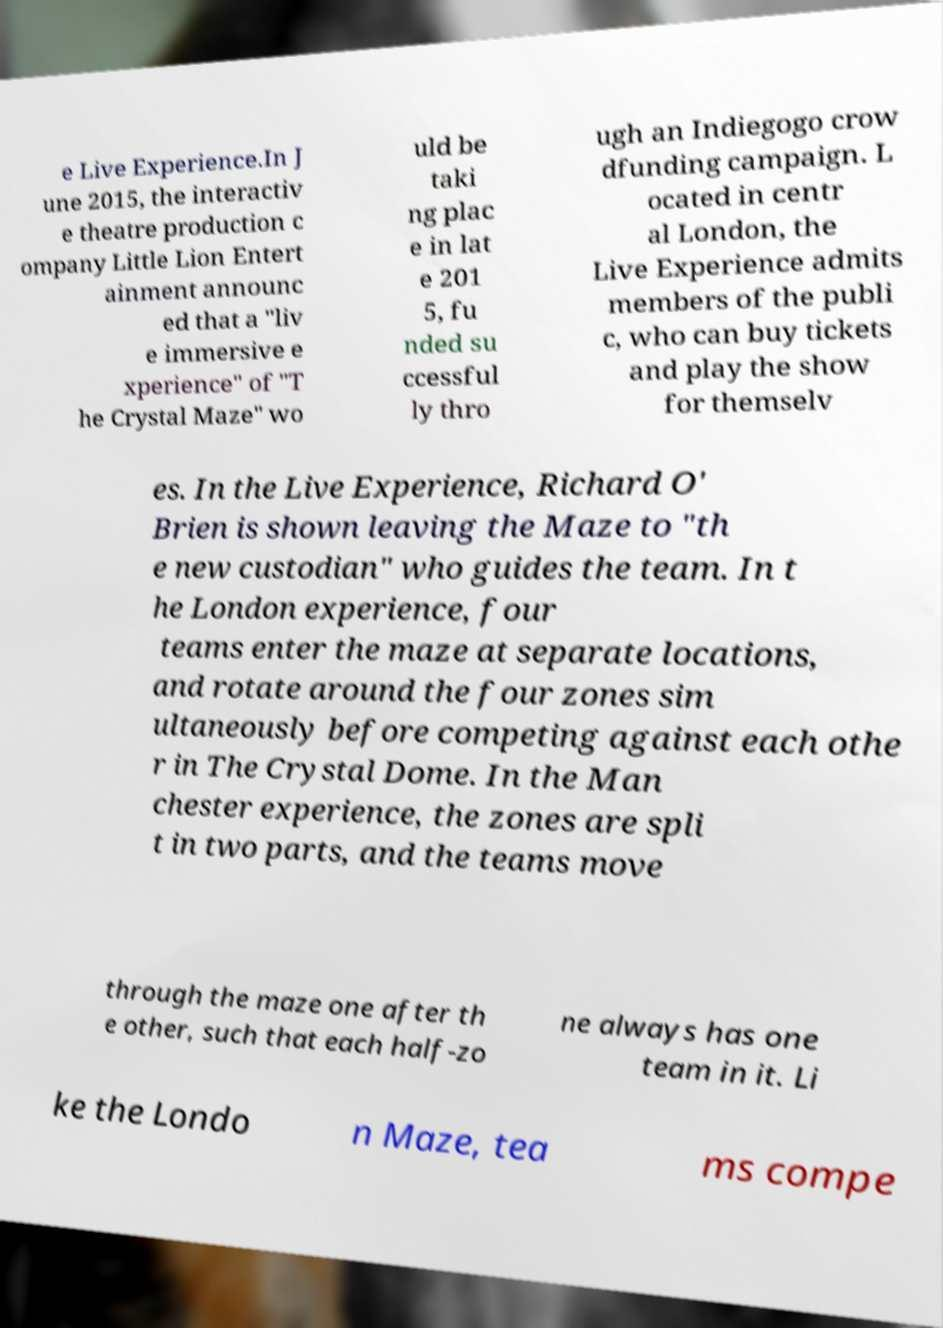For documentation purposes, I need the text within this image transcribed. Could you provide that? e Live Experience.In J une 2015, the interactiv e theatre production c ompany Little Lion Entert ainment announc ed that a "liv e immersive e xperience" of "T he Crystal Maze" wo uld be taki ng plac e in lat e 201 5, fu nded su ccessful ly thro ugh an Indiegogo crow dfunding campaign. L ocated in centr al London, the Live Experience admits members of the publi c, who can buy tickets and play the show for themselv es. In the Live Experience, Richard O' Brien is shown leaving the Maze to "th e new custodian" who guides the team. In t he London experience, four teams enter the maze at separate locations, and rotate around the four zones sim ultaneously before competing against each othe r in The Crystal Dome. In the Man chester experience, the zones are spli t in two parts, and the teams move through the maze one after th e other, such that each half-zo ne always has one team in it. Li ke the Londo n Maze, tea ms compe 